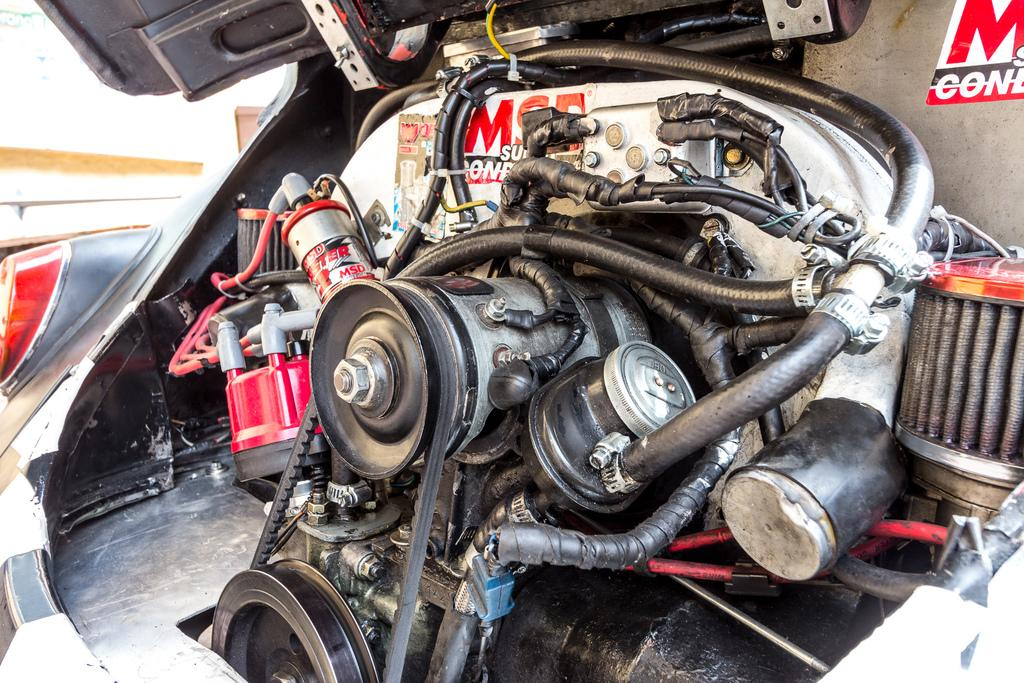What is the main subject in the foreground of the image? There is an engine part of a vehicle in the foreground of the image. Can you describe any other part of the vehicle visible in the image? Yes, there is a door of the vehicle visible at the top of the image. What type of quiver is hanging from the engine part in the image? There is no quiver present in the image; it features an engine part and a door of a vehicle. 